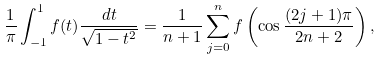Convert formula to latex. <formula><loc_0><loc_0><loc_500><loc_500>\frac { 1 } { \pi } \int _ { - 1 } ^ { 1 } f ( t ) \frac { d t } { \sqrt { 1 - t ^ { 2 } } } = \frac { 1 } { n + 1 } \sum _ { j = 0 } ^ { n } f \left ( \cos \frac { ( 2 j + 1 ) \pi } { 2 n + 2 } \right ) ,</formula> 